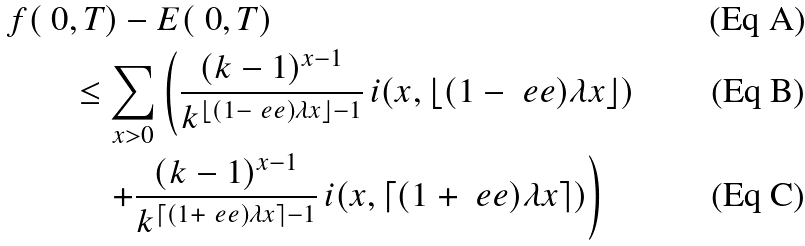<formula> <loc_0><loc_0><loc_500><loc_500>f ( \ 0 & , T ) - E ( \ 0 , T ) \\ & \leq \sum _ { x > 0 } \left ( \frac { ( k - 1 ) ^ { x - 1 } } { k ^ { \lfloor ( 1 - \ e e ) \lambda x \rfloor - 1 } } \, i ( x , \lfloor ( 1 - \ e e ) \lambda x \rfloor ) \right . \\ & \quad \left . + \frac { ( k - 1 ) ^ { x - 1 } } { k ^ { \lceil ( 1 + \ e e ) \lambda x \rceil - 1 } } \, i ( x , \lceil ( 1 + \ e e ) \lambda x \rceil ) \right )</formula> 